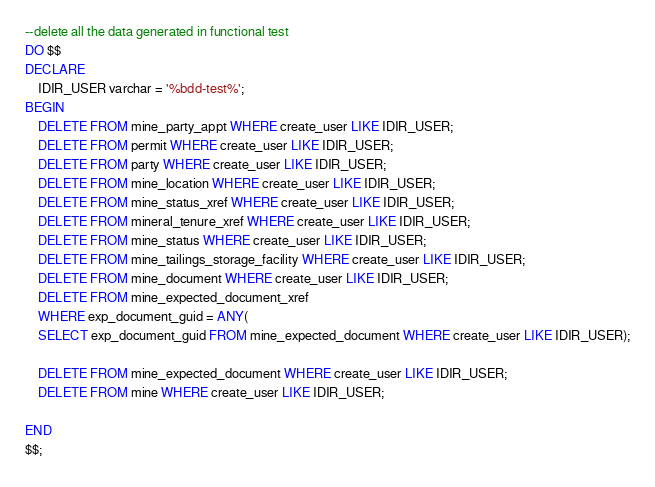<code> <loc_0><loc_0><loc_500><loc_500><_SQL_>--delete all the data generated in functional test
DO $$
DECLARE
    IDIR_USER varchar = '%bdd-test%';
BEGIN
    DELETE FROM mine_party_appt WHERE create_user LIKE IDIR_USER;
    DELETE FROM permit WHERE create_user LIKE IDIR_USER;
    DELETE FROM party WHERE create_user LIKE IDIR_USER;
    DELETE FROM mine_location WHERE create_user LIKE IDIR_USER;
    DELETE FROM mine_status_xref WHERE create_user LIKE IDIR_USER;
    DELETE FROM mineral_tenure_xref WHERE create_user LIKE IDIR_USER;
    DELETE FROM mine_status WHERE create_user LIKE IDIR_USER;
    DELETE FROM mine_tailings_storage_facility WHERE create_user LIKE IDIR_USER;
    DELETE FROM mine_document WHERE create_user LIKE IDIR_USER;
    DELETE FROM mine_expected_document_xref
    WHERE exp_document_guid = ANY(
    SELECT exp_document_guid FROM mine_expected_document WHERE create_user LIKE IDIR_USER);

    DELETE FROM mine_expected_document WHERE create_user LIKE IDIR_USER;
    DELETE FROM mine WHERE create_user LIKE IDIR_USER;

END
$$;
</code> 